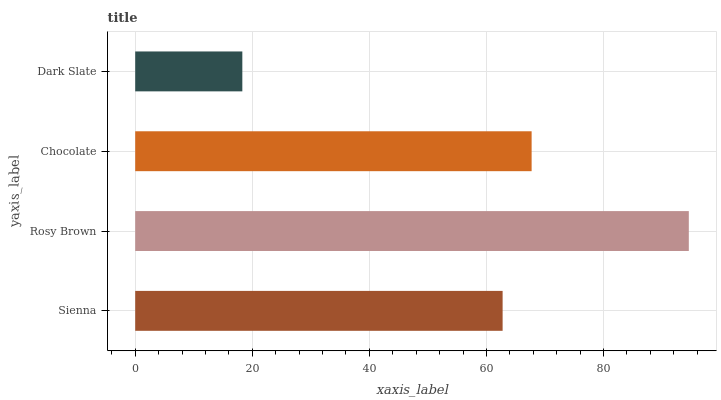Is Dark Slate the minimum?
Answer yes or no. Yes. Is Rosy Brown the maximum?
Answer yes or no. Yes. Is Chocolate the minimum?
Answer yes or no. No. Is Chocolate the maximum?
Answer yes or no. No. Is Rosy Brown greater than Chocolate?
Answer yes or no. Yes. Is Chocolate less than Rosy Brown?
Answer yes or no. Yes. Is Chocolate greater than Rosy Brown?
Answer yes or no. No. Is Rosy Brown less than Chocolate?
Answer yes or no. No. Is Chocolate the high median?
Answer yes or no. Yes. Is Sienna the low median?
Answer yes or no. Yes. Is Sienna the high median?
Answer yes or no. No. Is Dark Slate the low median?
Answer yes or no. No. 